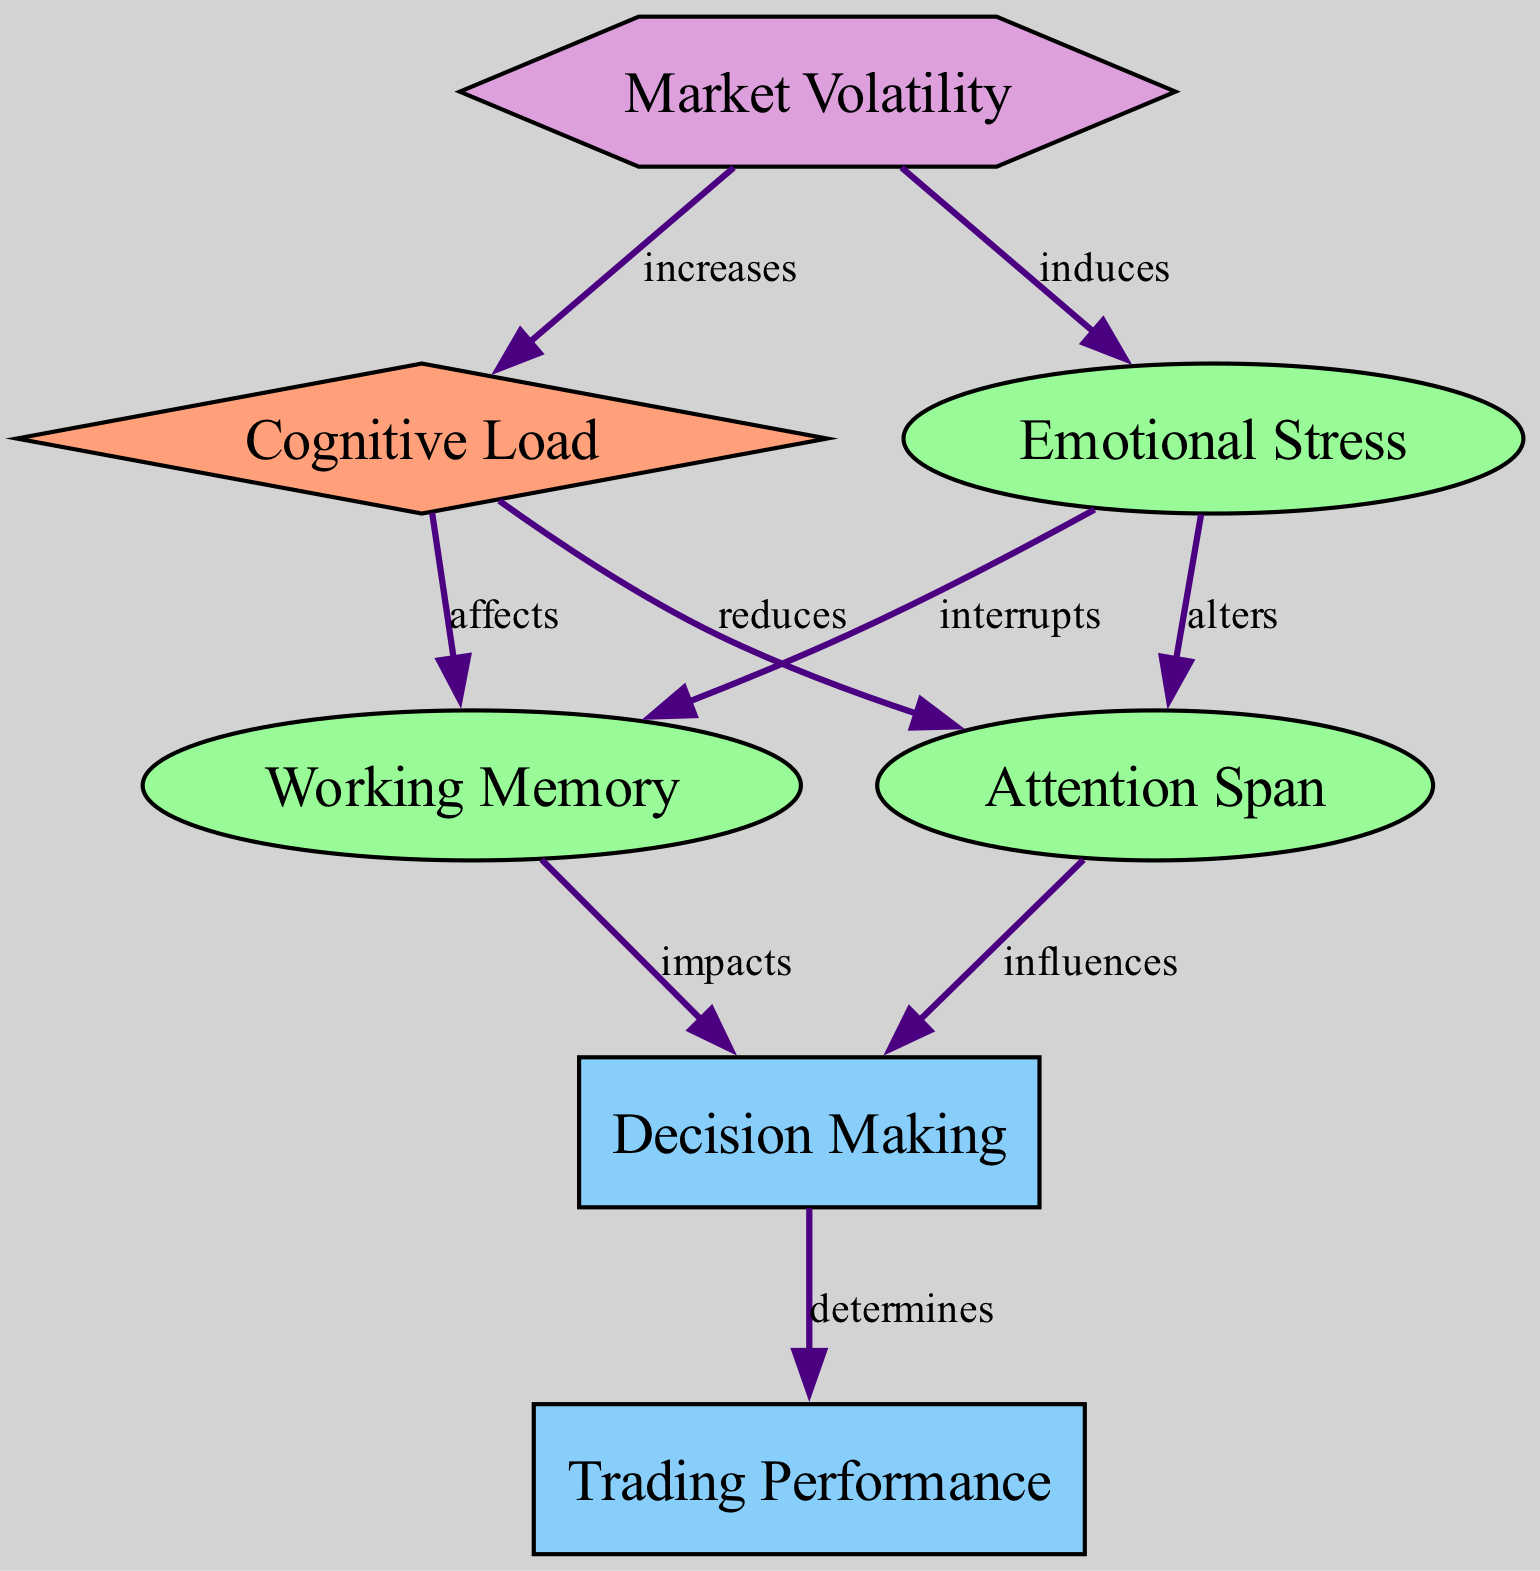What are the two main targets affected by cognitive load? The diagram identifies "Decision Making" and "Trading Performance" as the two targets that are directly affected by cognitive load, as indicated by their respective edges connecting from cognitive load.
Answer: Decision Making, Trading Performance How many edges are present in the diagram? By counting the connections between nodes in the diagram, there are a total of eight edges that link the various nodes together, indicating the relationships and effects among them.
Answer: Eight Which process does emotional stress interrupt? The diagram shows that emotional stress interrupts "Working Memory"; this is conveyed through the edge connecting emotional stress to working memory specifically.
Answer: Working Memory What does increased market volatility induce? According to the diagram, increased market volatility induces "Emotional Stress," which is shown by the edge connecting market volatility to emotional stress.
Answer: Emotional Stress How does cognitive load affect attention span? The diagram explicitly states that cognitive load reduces attention span, represented by the edge from cognitive load to attention span, which indicates a negative influence.
Answer: Reduces Which two processes influence decision making? The diagram indicates that "Working Memory" and "Attention Span" both influence "Decision Making", as they have direct edges pointing to the decision-making node.
Answer: Working Memory, Attention Span What does emotional stress do to working memory? The diagram illustrates that emotional stress alters working memory, as depicted by the connection from emotional stress to working memory, implying a change in its capacity or function.
Answer: Alters What is the context that increases cognitive load? The diagram specifies that "Market Volatility" increases cognitive load, which is represented by the edge going from market volatility to cognitive load, indicating a direct relationship.
Answer: Market Volatility 